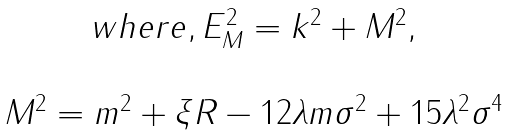<formula> <loc_0><loc_0><loc_500><loc_500>\begin{array} { c } w h e r e , E _ { M } ^ { 2 } = k ^ { 2 } + M ^ { 2 } , \\ \\ M ^ { 2 } = m ^ { 2 } + \xi R - 1 2 \lambda m \sigma ^ { 2 } + 1 5 \lambda ^ { 2 } \sigma ^ { 4 } \end{array}</formula> 